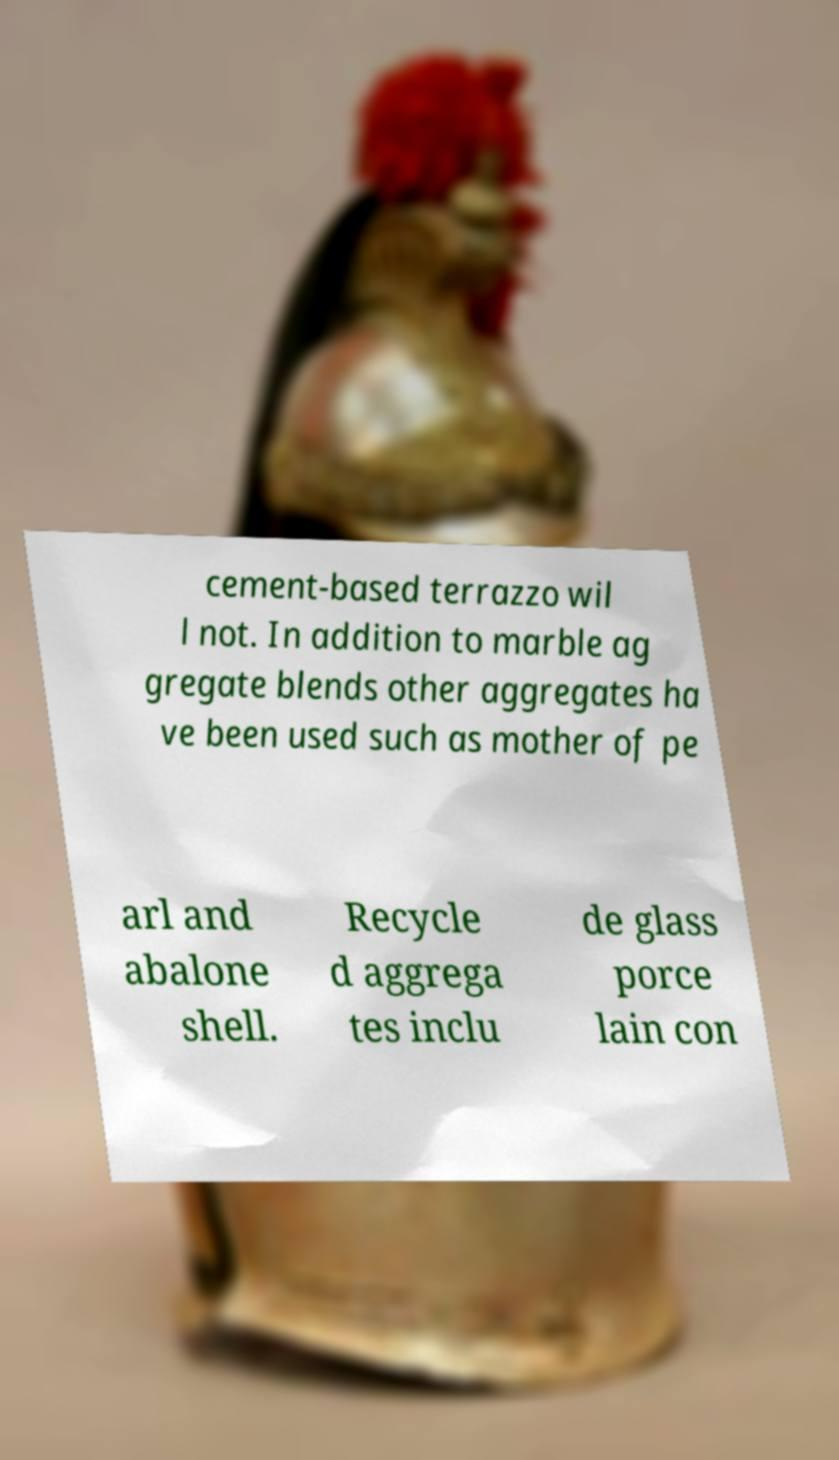Could you extract and type out the text from this image? cement-based terrazzo wil l not. In addition to marble ag gregate blends other aggregates ha ve been used such as mother of pe arl and abalone shell. Recycle d aggrega tes inclu de glass porce lain con 